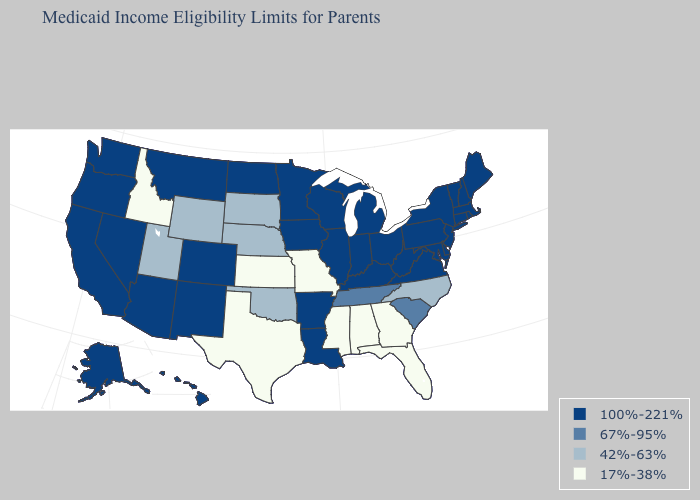What is the lowest value in the USA?
Short answer required. 17%-38%. Name the states that have a value in the range 42%-63%?
Be succinct. Nebraska, North Carolina, Oklahoma, South Dakota, Utah, Wyoming. Does the map have missing data?
Answer briefly. No. What is the lowest value in the USA?
Concise answer only. 17%-38%. What is the highest value in states that border Rhode Island?
Short answer required. 100%-221%. Does West Virginia have the same value as Texas?
Write a very short answer. No. Name the states that have a value in the range 100%-221%?
Short answer required. Alaska, Arizona, Arkansas, California, Colorado, Connecticut, Delaware, Hawaii, Illinois, Indiana, Iowa, Kentucky, Louisiana, Maine, Maryland, Massachusetts, Michigan, Minnesota, Montana, Nevada, New Hampshire, New Jersey, New Mexico, New York, North Dakota, Ohio, Oregon, Pennsylvania, Rhode Island, Vermont, Virginia, Washington, West Virginia, Wisconsin. What is the value of Nevada?
Answer briefly. 100%-221%. What is the value of West Virginia?
Short answer required. 100%-221%. Name the states that have a value in the range 42%-63%?
Short answer required. Nebraska, North Carolina, Oklahoma, South Dakota, Utah, Wyoming. Which states have the lowest value in the MidWest?
Answer briefly. Kansas, Missouri. What is the highest value in states that border Colorado?
Answer briefly. 100%-221%. Which states have the lowest value in the USA?
Quick response, please. Alabama, Florida, Georgia, Idaho, Kansas, Mississippi, Missouri, Texas. Does Wisconsin have the highest value in the MidWest?
Concise answer only. Yes. Name the states that have a value in the range 42%-63%?
Keep it brief. Nebraska, North Carolina, Oklahoma, South Dakota, Utah, Wyoming. 